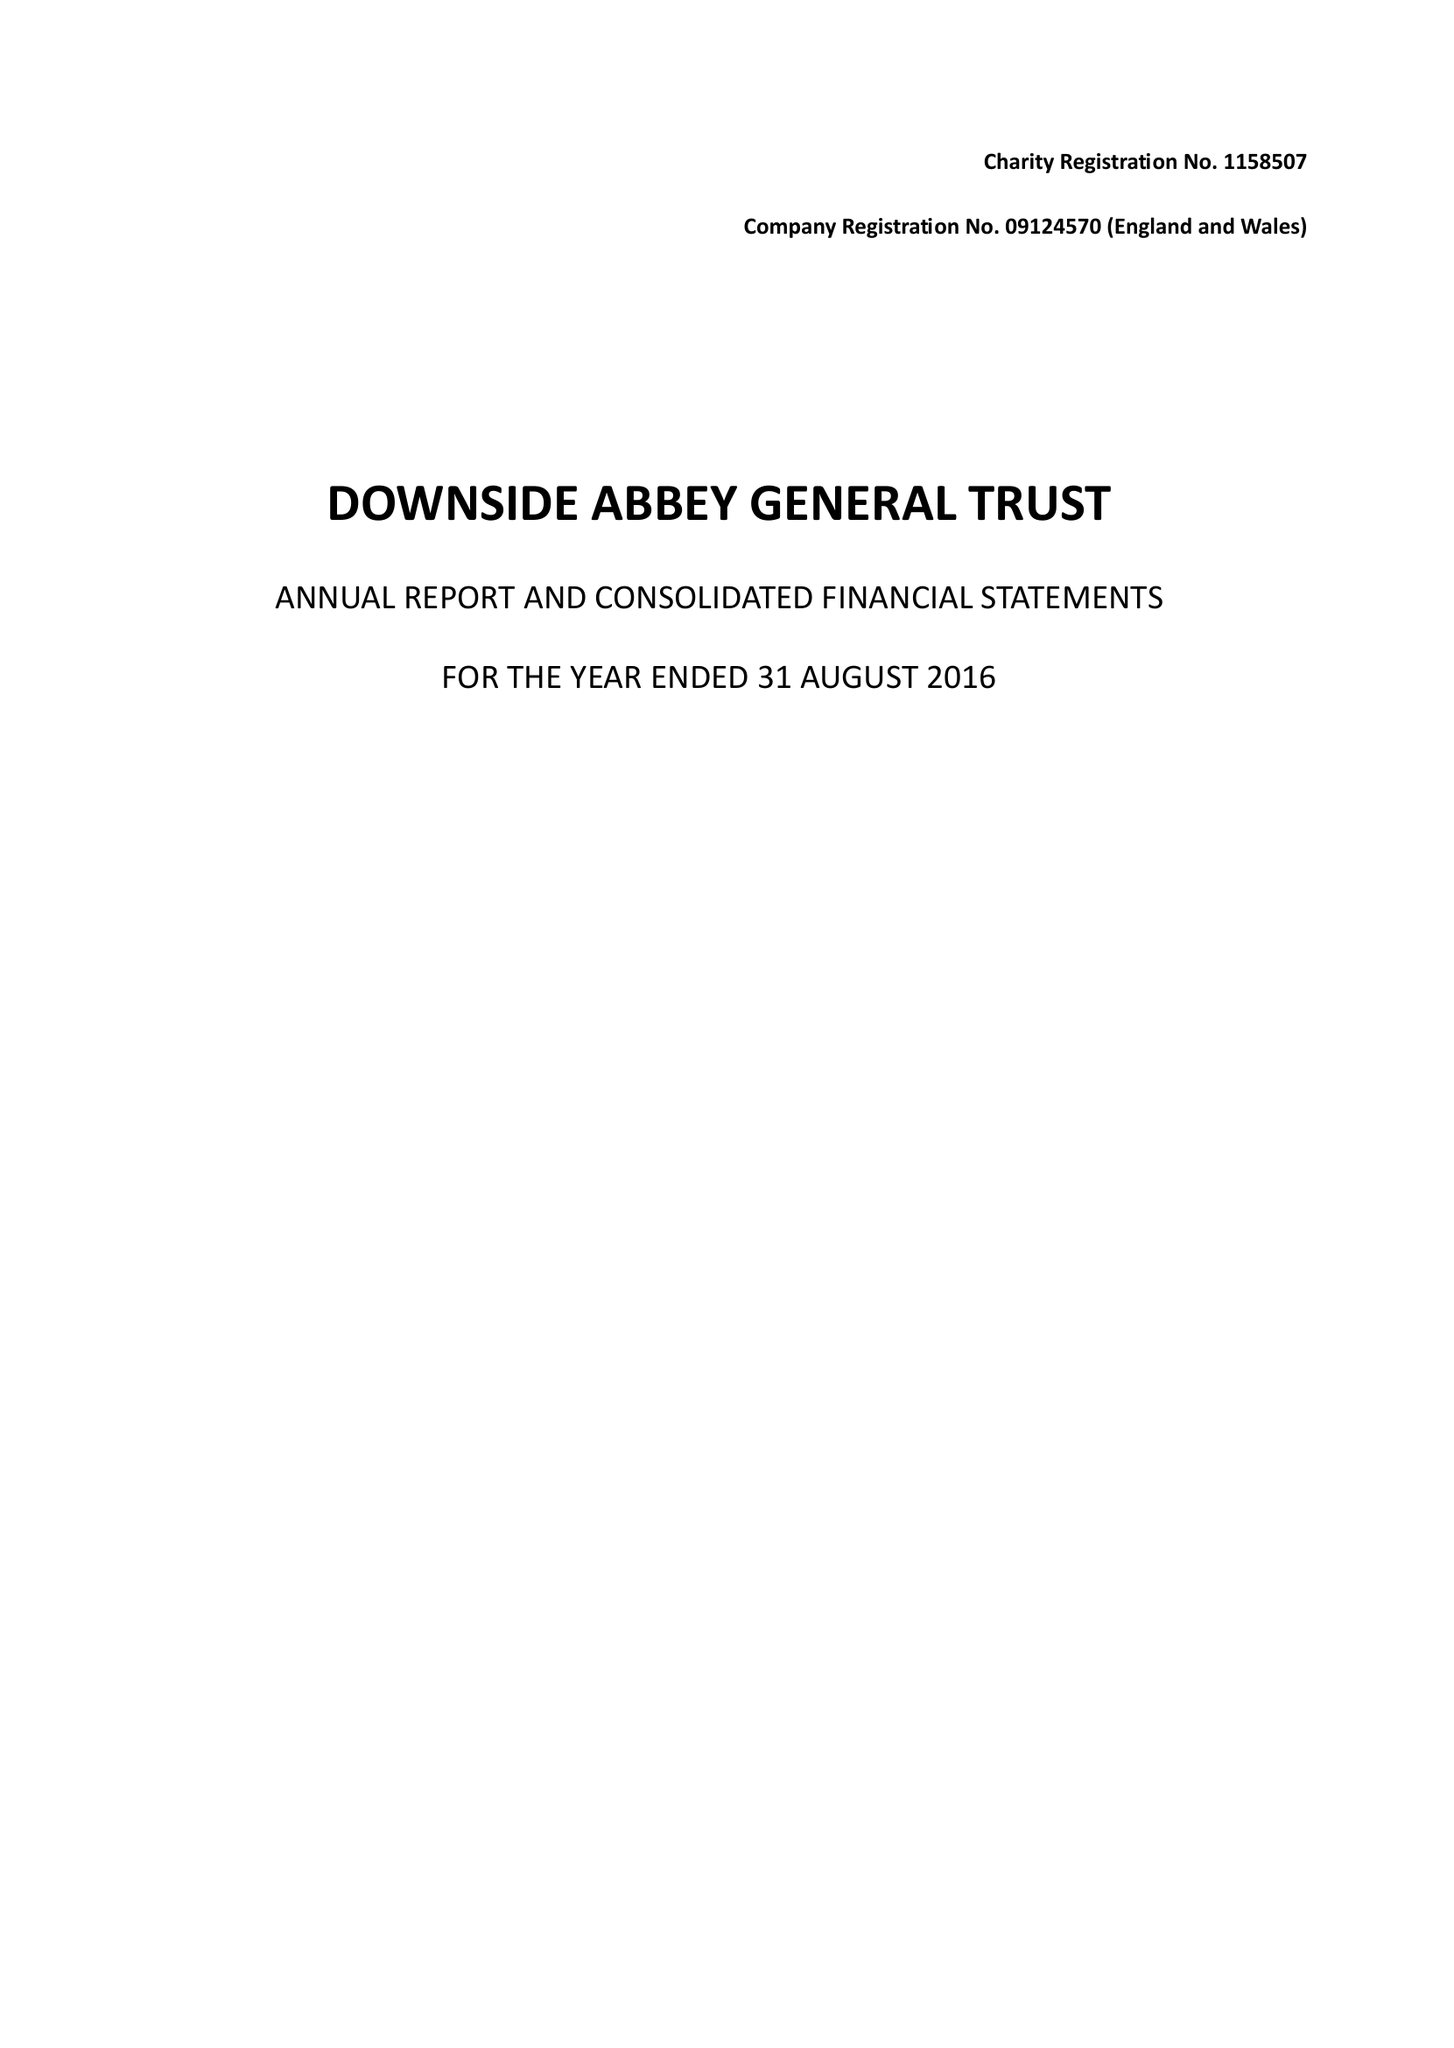What is the value for the charity_name?
Answer the question using a single word or phrase. Downside Abbey General Trust 